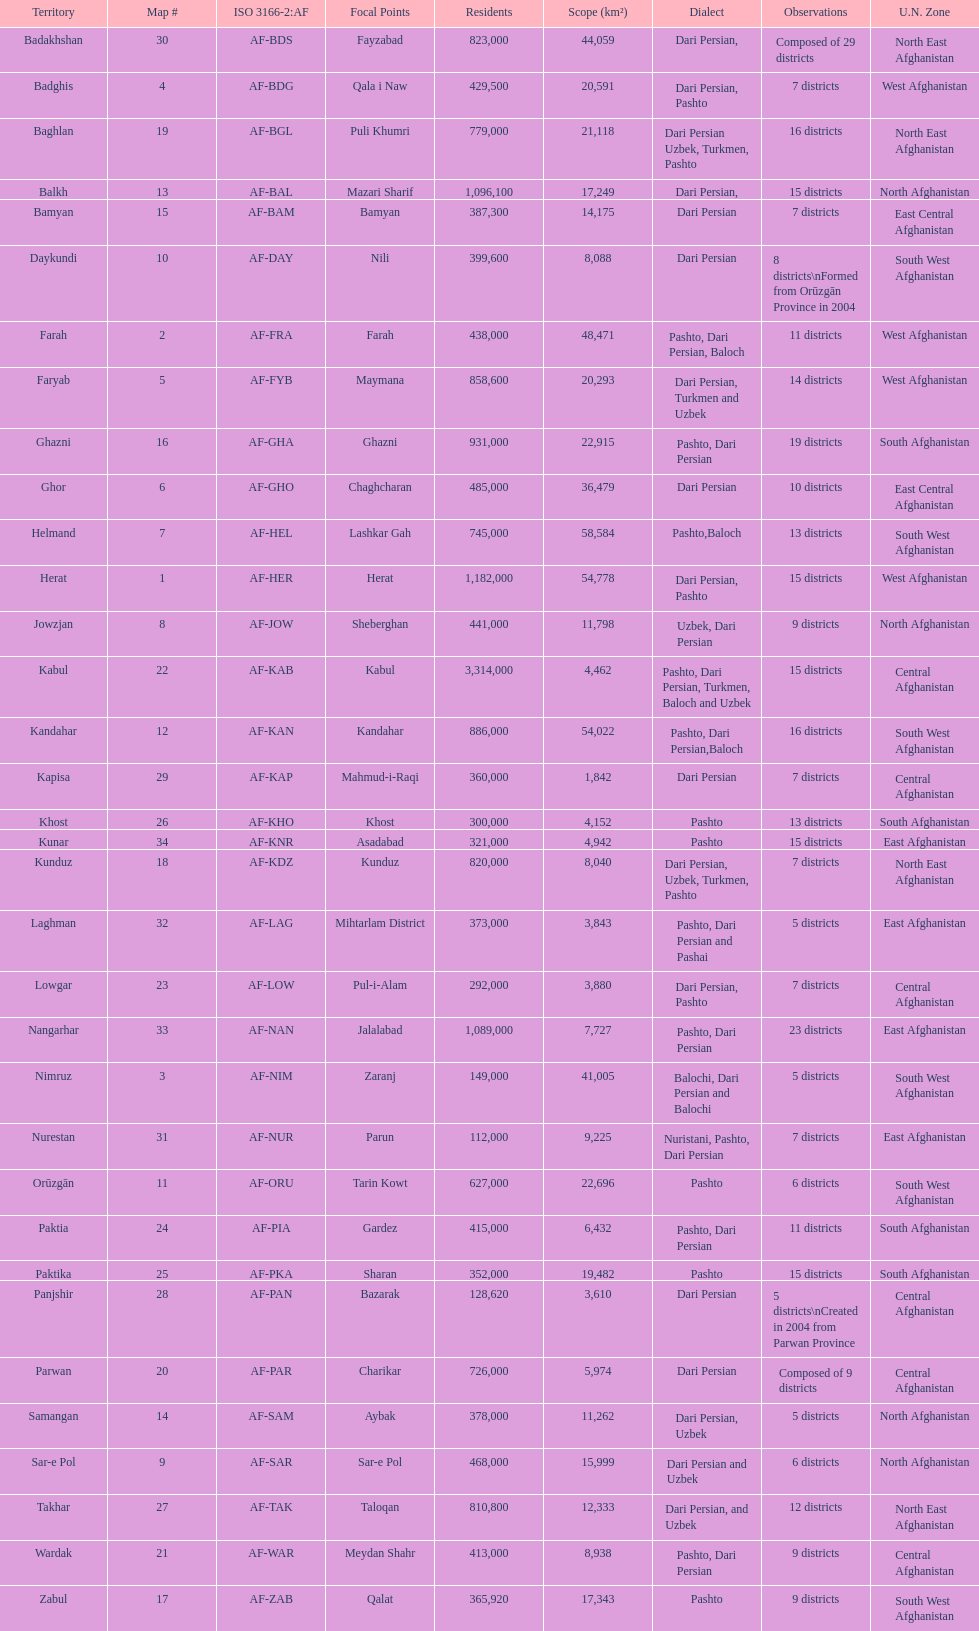Could you help me parse every detail presented in this table? {'header': ['Territory', 'Map #', 'ISO 3166-2:AF', 'Focal Points', 'Residents', 'Scope (km²)', 'Dialect', 'Observations', 'U.N. Zone'], 'rows': [['Badakhshan', '30', 'AF-BDS', 'Fayzabad', '823,000', '44,059', 'Dari Persian,', 'Composed of 29 districts', 'North East Afghanistan'], ['Badghis', '4', 'AF-BDG', 'Qala i Naw', '429,500', '20,591', 'Dari Persian, Pashto', '7 districts', 'West Afghanistan'], ['Baghlan', '19', 'AF-BGL', 'Puli Khumri', '779,000', '21,118', 'Dari Persian Uzbek, Turkmen, Pashto', '16 districts', 'North East Afghanistan'], ['Balkh', '13', 'AF-BAL', 'Mazari Sharif', '1,096,100', '17,249', 'Dari Persian,', '15 districts', 'North Afghanistan'], ['Bamyan', '15', 'AF-BAM', 'Bamyan', '387,300', '14,175', 'Dari Persian', '7 districts', 'East Central Afghanistan'], ['Daykundi', '10', 'AF-DAY', 'Nili', '399,600', '8,088', 'Dari Persian', '8 districts\\nFormed from Orūzgān Province in 2004', 'South West Afghanistan'], ['Farah', '2', 'AF-FRA', 'Farah', '438,000', '48,471', 'Pashto, Dari Persian, Baloch', '11 districts', 'West Afghanistan'], ['Faryab', '5', 'AF-FYB', 'Maymana', '858,600', '20,293', 'Dari Persian, Turkmen and Uzbek', '14 districts', 'West Afghanistan'], ['Ghazni', '16', 'AF-GHA', 'Ghazni', '931,000', '22,915', 'Pashto, Dari Persian', '19 districts', 'South Afghanistan'], ['Ghor', '6', 'AF-GHO', 'Chaghcharan', '485,000', '36,479', 'Dari Persian', '10 districts', 'East Central Afghanistan'], ['Helmand', '7', 'AF-HEL', 'Lashkar Gah', '745,000', '58,584', 'Pashto,Baloch', '13 districts', 'South West Afghanistan'], ['Herat', '1', 'AF-HER', 'Herat', '1,182,000', '54,778', 'Dari Persian, Pashto', '15 districts', 'West Afghanistan'], ['Jowzjan', '8', 'AF-JOW', 'Sheberghan', '441,000', '11,798', 'Uzbek, Dari Persian', '9 districts', 'North Afghanistan'], ['Kabul', '22', 'AF-KAB', 'Kabul', '3,314,000', '4,462', 'Pashto, Dari Persian, Turkmen, Baloch and Uzbek', '15 districts', 'Central Afghanistan'], ['Kandahar', '12', 'AF-KAN', 'Kandahar', '886,000', '54,022', 'Pashto, Dari Persian,Baloch', '16 districts', 'South West Afghanistan'], ['Kapisa', '29', 'AF-KAP', 'Mahmud-i-Raqi', '360,000', '1,842', 'Dari Persian', '7 districts', 'Central Afghanistan'], ['Khost', '26', 'AF-KHO', 'Khost', '300,000', '4,152', 'Pashto', '13 districts', 'South Afghanistan'], ['Kunar', '34', 'AF-KNR', 'Asadabad', '321,000', '4,942', 'Pashto', '15 districts', 'East Afghanistan'], ['Kunduz', '18', 'AF-KDZ', 'Kunduz', '820,000', '8,040', 'Dari Persian, Uzbek, Turkmen, Pashto', '7 districts', 'North East Afghanistan'], ['Laghman', '32', 'AF-LAG', 'Mihtarlam District', '373,000', '3,843', 'Pashto, Dari Persian and Pashai', '5 districts', 'East Afghanistan'], ['Lowgar', '23', 'AF-LOW', 'Pul-i-Alam', '292,000', '3,880', 'Dari Persian, Pashto', '7 districts', 'Central Afghanistan'], ['Nangarhar', '33', 'AF-NAN', 'Jalalabad', '1,089,000', '7,727', 'Pashto, Dari Persian', '23 districts', 'East Afghanistan'], ['Nimruz', '3', 'AF-NIM', 'Zaranj', '149,000', '41,005', 'Balochi, Dari Persian and Balochi', '5 districts', 'South West Afghanistan'], ['Nurestan', '31', 'AF-NUR', 'Parun', '112,000', '9,225', 'Nuristani, Pashto, Dari Persian', '7 districts', 'East Afghanistan'], ['Orūzgān', '11', 'AF-ORU', 'Tarin Kowt', '627,000', '22,696', 'Pashto', '6 districts', 'South West Afghanistan'], ['Paktia', '24', 'AF-PIA', 'Gardez', '415,000', '6,432', 'Pashto, Dari Persian', '11 districts', 'South Afghanistan'], ['Paktika', '25', 'AF-PKA', 'Sharan', '352,000', '19,482', 'Pashto', '15 districts', 'South Afghanistan'], ['Panjshir', '28', 'AF-PAN', 'Bazarak', '128,620', '3,610', 'Dari Persian', '5 districts\\nCreated in 2004 from Parwan Province', 'Central Afghanistan'], ['Parwan', '20', 'AF-PAR', 'Charikar', '726,000', '5,974', 'Dari Persian', 'Composed of 9 districts', 'Central Afghanistan'], ['Samangan', '14', 'AF-SAM', 'Aybak', '378,000', '11,262', 'Dari Persian, Uzbek', '5 districts', 'North Afghanistan'], ['Sar-e Pol', '9', 'AF-SAR', 'Sar-e Pol', '468,000', '15,999', 'Dari Persian and Uzbek', '6 districts', 'North Afghanistan'], ['Takhar', '27', 'AF-TAK', 'Taloqan', '810,800', '12,333', 'Dari Persian, and Uzbek', '12 districts', 'North East Afghanistan'], ['Wardak', '21', 'AF-WAR', 'Meydan Shahr', '413,000', '8,938', 'Pashto, Dari Persian', '9 districts', 'Central Afghanistan'], ['Zabul', '17', 'AF-ZAB', 'Qalat', '365,920', '17,343', 'Pashto', '9 districts', 'South West Afghanistan']]} What province is listed previous to ghor? Ghazni. 